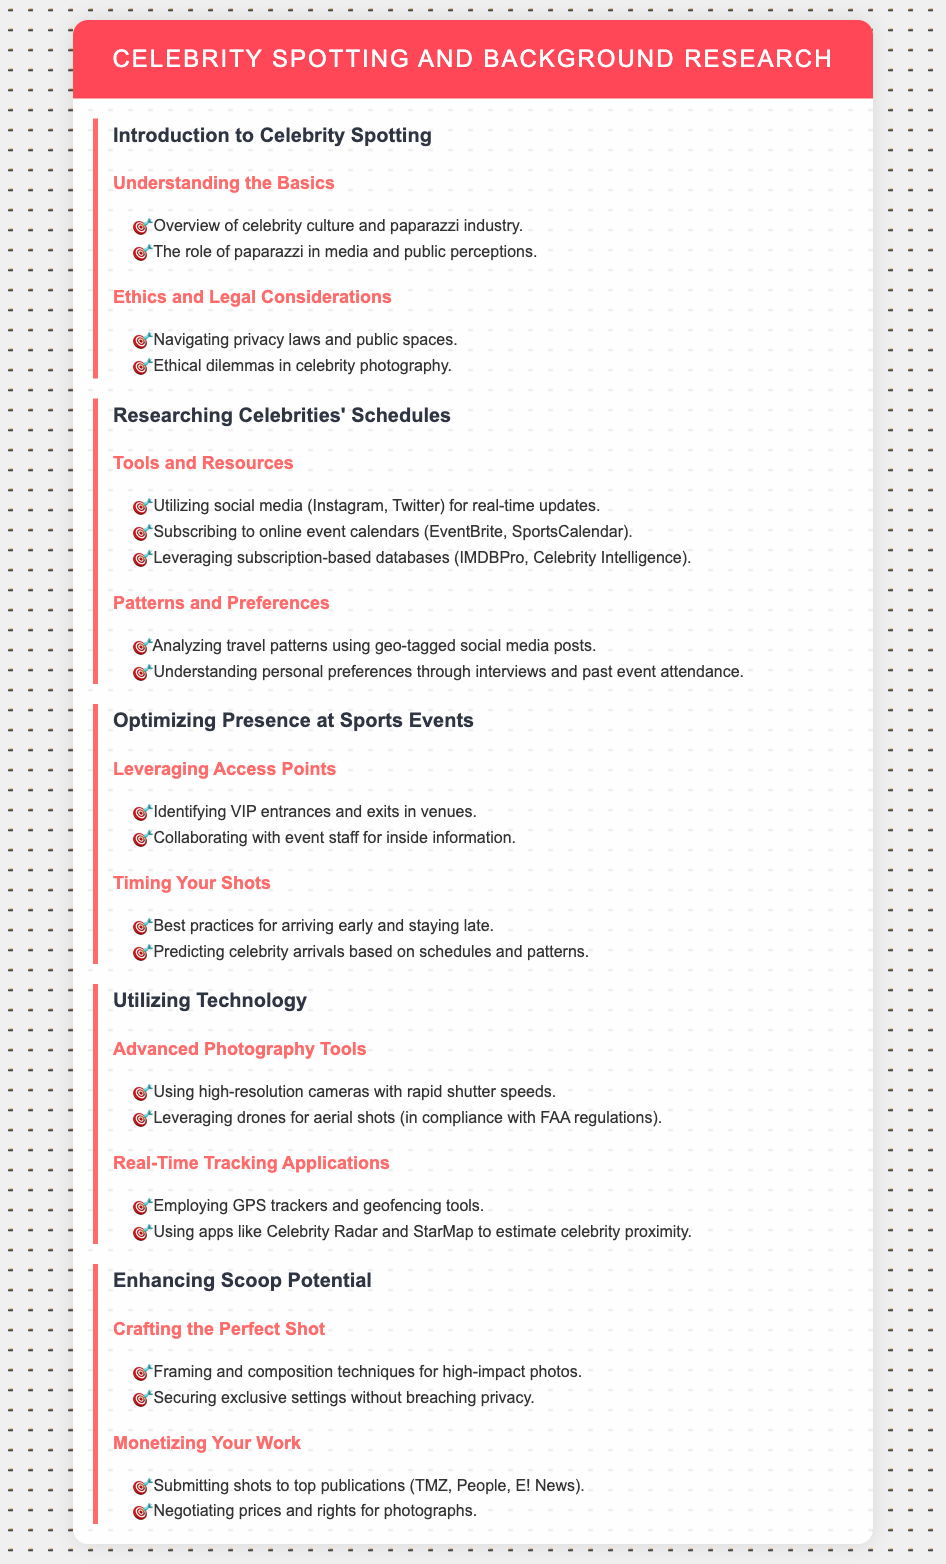What is the title of the syllabus? The title of the syllabus is located at the top of the document in the header.
Answer: Celebrity Spotting and Background Research What are two resources for researching celebrities' schedules? The document lists tools and resources for researching celebrities' schedules in one of the modules, showcasing specific examples.
Answer: Instagram, EventBrite What is one ethical consideration mentioned in the syllabus? The syllabus includes a list of ethical dilemmas in celebrity photography, which is part of the ethics and legal considerations module.
Answer: Privacy laws How can paparazzi optimize their presence at sports events? This question considers methods from the module about optimizing presence, highlighting specific tools and strategies.
Answer: Timing your shots What is a technology mentioned that helps with real-time tracking? The syllabus states certain applications under the technology module, pointing to tools that aid paparazzi.
Answer: Celebrity Radar What should photographers leverage for aerial shots? The document advises on using specific tools and methods when discussing advanced photography tools.
Answer: Drones List one best practice for arriving at events. The document discusses best practices for arriving early and staying late in the context of timing your shots.
Answer: Arriving early What is one suggested strategy for monetizing photographs? This question relates to the module on enhancing scoop potential, specifically focusing on financial aspects.
Answer: Submitting shots to top publications 